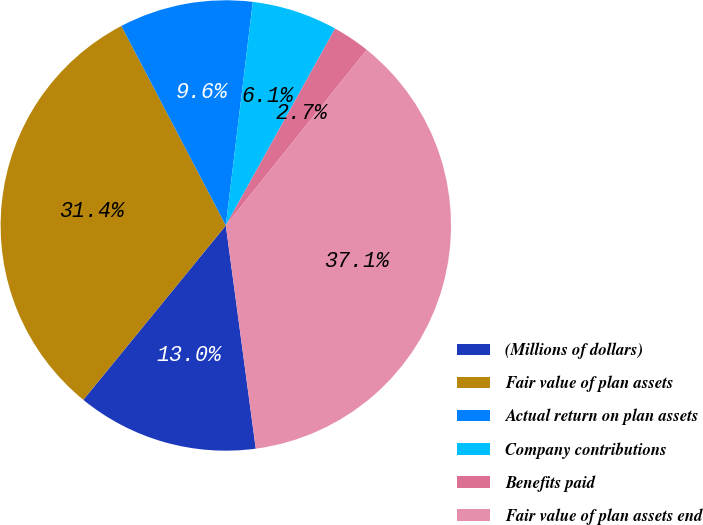Convert chart. <chart><loc_0><loc_0><loc_500><loc_500><pie_chart><fcel>(Millions of dollars)<fcel>Fair value of plan assets<fcel>Actual return on plan assets<fcel>Company contributions<fcel>Benefits paid<fcel>Fair value of plan assets end<nl><fcel>13.03%<fcel>31.42%<fcel>9.59%<fcel>6.15%<fcel>2.7%<fcel>37.12%<nl></chart> 